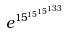Convert formula to latex. <formula><loc_0><loc_0><loc_500><loc_500>e ^ { 1 5 ^ { 1 5 ^ { 1 5 ^ { 1 3 3 } } } }</formula> 